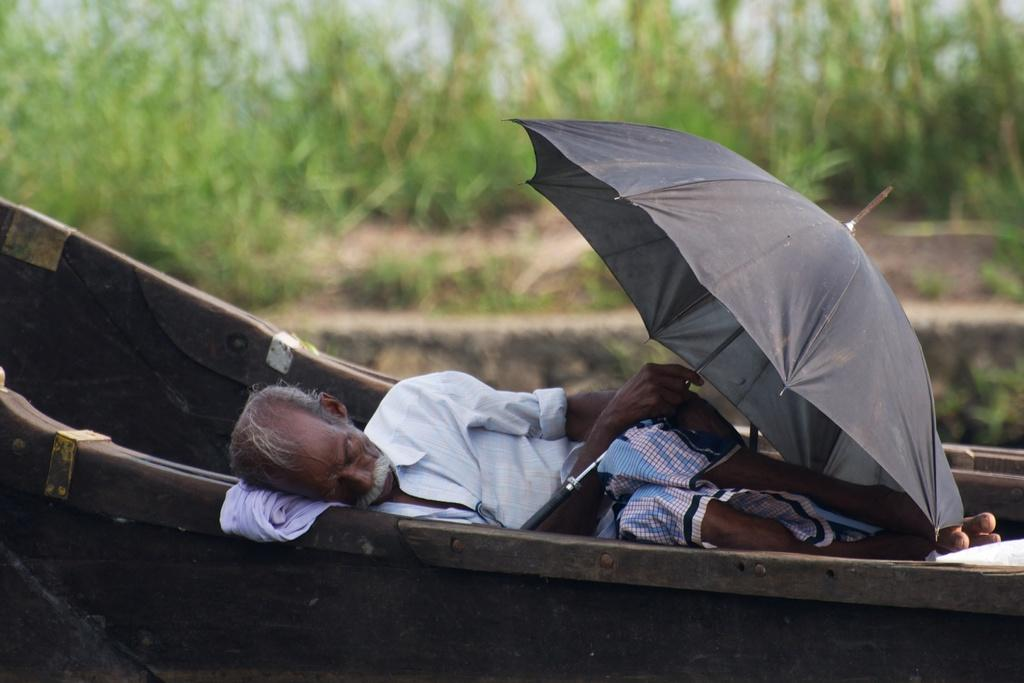What is the man in the image doing? The man is lying on a boat in the image. What is the man holding in the image? The man is holding an umbrella in the image. What can be seen in the background of the image? There are plants in the background of the image. How would you describe the clarity of the image? The image is blurred. How does the man's digestion appear to be affected by the boat ride in the image? There is no indication of the man's digestion in the image, as it only shows him lying on a boat and holding an umbrella. 